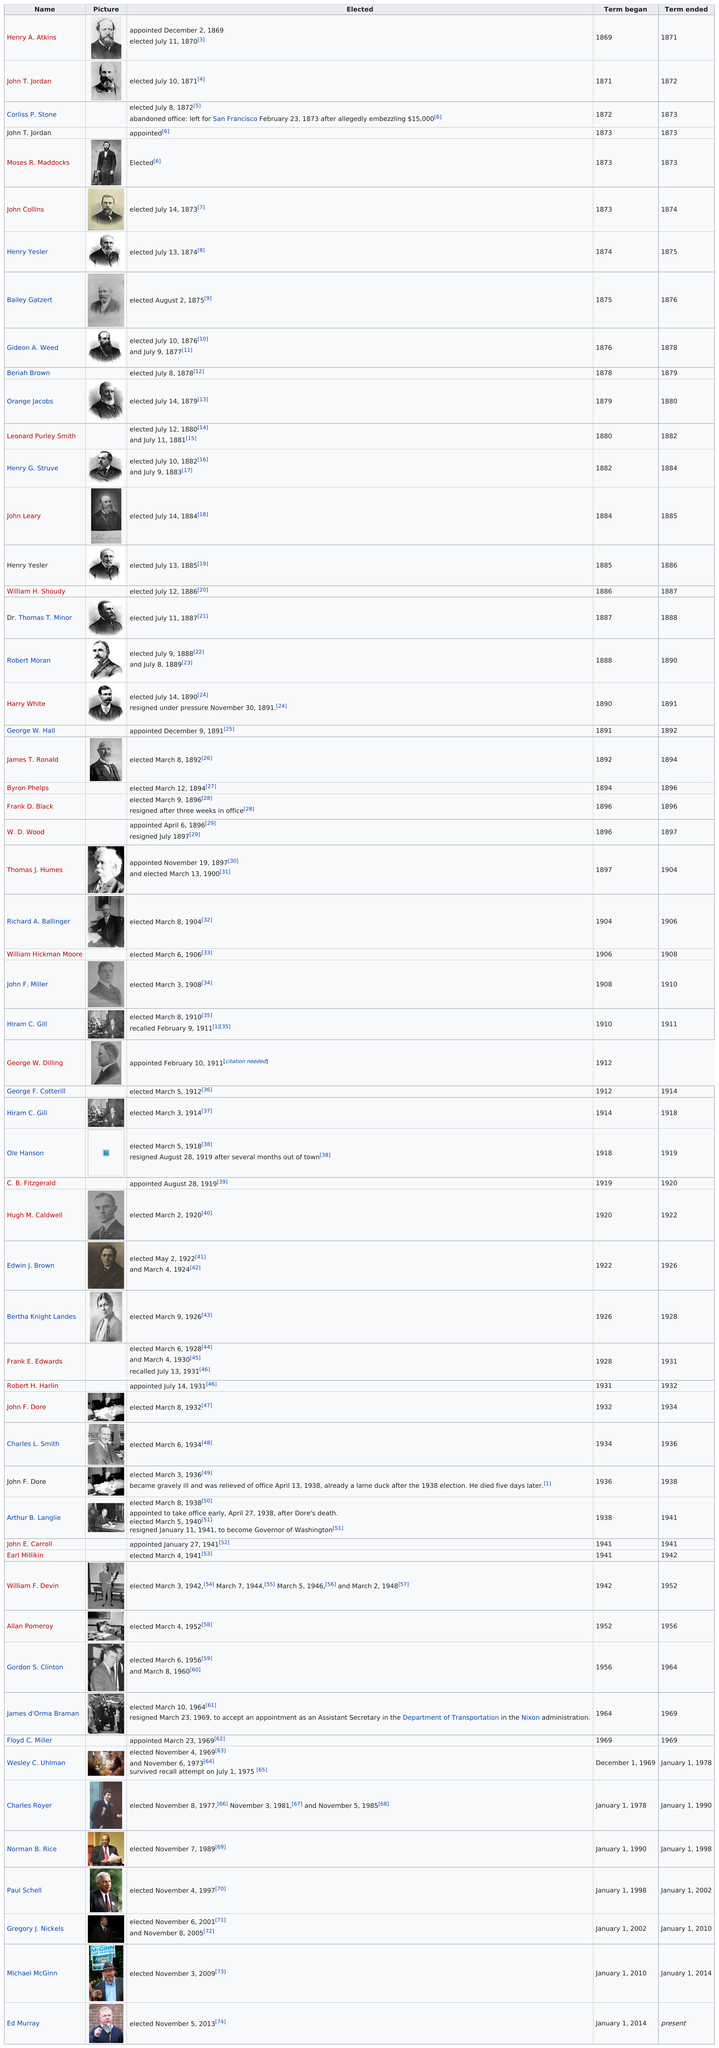Point out several critical features in this image. It is documented that 1 woman has been elected mayor of Seattle, Washington. Frank D. Black, the mayor of Seattle, Washington, resigned after only three weeks in office in 1896. Who began their term in 1890? Harry White did. Charles Royer held office for a longer period of time than Paul Schell. Richard A. Ballinger was the first mayor in the 1900's. 